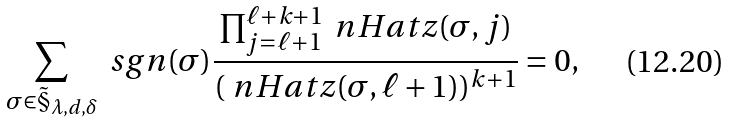Convert formula to latex. <formula><loc_0><loc_0><loc_500><loc_500>\sum _ { \sigma \in \tilde { \S } _ { \lambda , d , \delta } } \ s g n ( \sigma ) \frac { \prod _ { j = \ell + 1 } ^ { \ell + k + 1 } \ n H a t { z } ( \sigma , j ) } { ( \ n H a t { z } ( \sigma , \ell + 1 ) ) ^ { k + 1 } } = 0 ,</formula> 